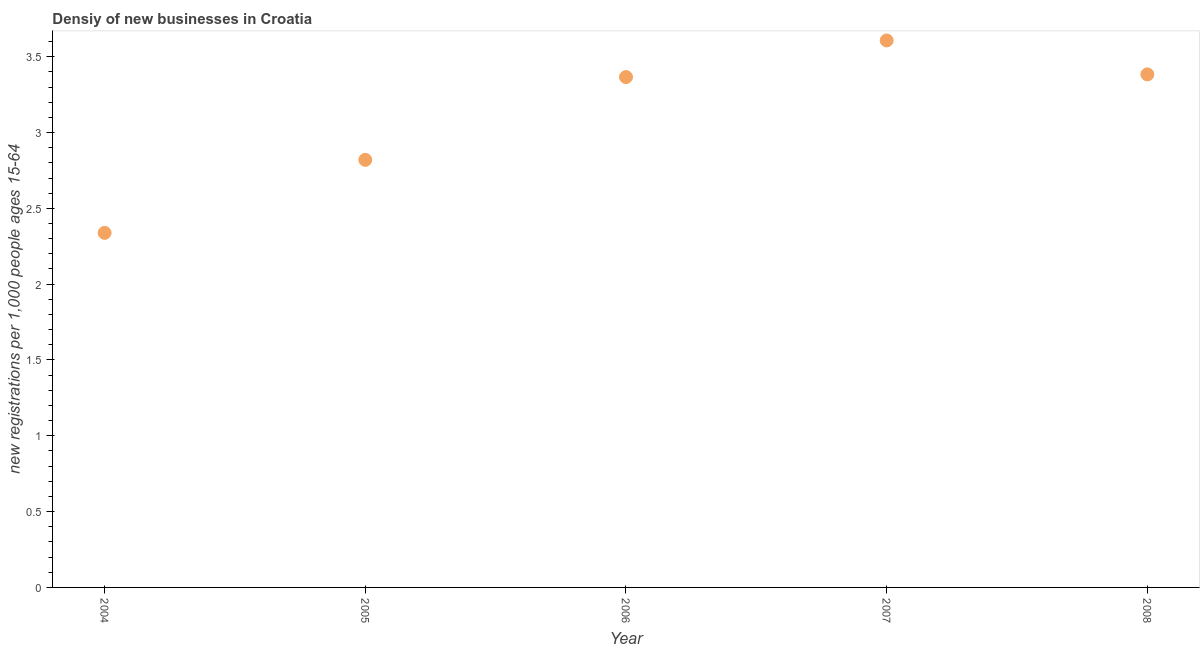What is the density of new business in 2006?
Provide a short and direct response. 3.37. Across all years, what is the maximum density of new business?
Your response must be concise. 3.61. Across all years, what is the minimum density of new business?
Provide a succinct answer. 2.34. What is the sum of the density of new business?
Your response must be concise. 15.51. What is the difference between the density of new business in 2004 and 2008?
Your answer should be very brief. -1.05. What is the average density of new business per year?
Provide a succinct answer. 3.1. What is the median density of new business?
Your answer should be compact. 3.37. Do a majority of the years between 2007 and 2005 (inclusive) have density of new business greater than 0.1 ?
Offer a terse response. No. What is the ratio of the density of new business in 2005 to that in 2007?
Offer a very short reply. 0.78. What is the difference between the highest and the second highest density of new business?
Your answer should be compact. 0.22. What is the difference between the highest and the lowest density of new business?
Give a very brief answer. 1.27. How many years are there in the graph?
Keep it short and to the point. 5. What is the difference between two consecutive major ticks on the Y-axis?
Offer a terse response. 0.5. Does the graph contain any zero values?
Offer a terse response. No. What is the title of the graph?
Provide a short and direct response. Densiy of new businesses in Croatia. What is the label or title of the X-axis?
Your response must be concise. Year. What is the label or title of the Y-axis?
Your answer should be compact. New registrations per 1,0 people ages 15-64. What is the new registrations per 1,000 people ages 15-64 in 2004?
Offer a terse response. 2.34. What is the new registrations per 1,000 people ages 15-64 in 2005?
Your answer should be very brief. 2.82. What is the new registrations per 1,000 people ages 15-64 in 2006?
Your answer should be compact. 3.37. What is the new registrations per 1,000 people ages 15-64 in 2007?
Your response must be concise. 3.61. What is the new registrations per 1,000 people ages 15-64 in 2008?
Your response must be concise. 3.38. What is the difference between the new registrations per 1,000 people ages 15-64 in 2004 and 2005?
Keep it short and to the point. -0.48. What is the difference between the new registrations per 1,000 people ages 15-64 in 2004 and 2006?
Give a very brief answer. -1.03. What is the difference between the new registrations per 1,000 people ages 15-64 in 2004 and 2007?
Keep it short and to the point. -1.27. What is the difference between the new registrations per 1,000 people ages 15-64 in 2004 and 2008?
Keep it short and to the point. -1.05. What is the difference between the new registrations per 1,000 people ages 15-64 in 2005 and 2006?
Your response must be concise. -0.55. What is the difference between the new registrations per 1,000 people ages 15-64 in 2005 and 2007?
Your response must be concise. -0.79. What is the difference between the new registrations per 1,000 people ages 15-64 in 2005 and 2008?
Make the answer very short. -0.56. What is the difference between the new registrations per 1,000 people ages 15-64 in 2006 and 2007?
Provide a succinct answer. -0.24. What is the difference between the new registrations per 1,000 people ages 15-64 in 2006 and 2008?
Offer a very short reply. -0.02. What is the difference between the new registrations per 1,000 people ages 15-64 in 2007 and 2008?
Make the answer very short. 0.22. What is the ratio of the new registrations per 1,000 people ages 15-64 in 2004 to that in 2005?
Provide a short and direct response. 0.83. What is the ratio of the new registrations per 1,000 people ages 15-64 in 2004 to that in 2006?
Provide a succinct answer. 0.69. What is the ratio of the new registrations per 1,000 people ages 15-64 in 2004 to that in 2007?
Offer a very short reply. 0.65. What is the ratio of the new registrations per 1,000 people ages 15-64 in 2004 to that in 2008?
Ensure brevity in your answer.  0.69. What is the ratio of the new registrations per 1,000 people ages 15-64 in 2005 to that in 2006?
Your response must be concise. 0.84. What is the ratio of the new registrations per 1,000 people ages 15-64 in 2005 to that in 2007?
Provide a short and direct response. 0.78. What is the ratio of the new registrations per 1,000 people ages 15-64 in 2005 to that in 2008?
Give a very brief answer. 0.83. What is the ratio of the new registrations per 1,000 people ages 15-64 in 2006 to that in 2007?
Make the answer very short. 0.93. What is the ratio of the new registrations per 1,000 people ages 15-64 in 2006 to that in 2008?
Your response must be concise. 0.99. What is the ratio of the new registrations per 1,000 people ages 15-64 in 2007 to that in 2008?
Make the answer very short. 1.07. 